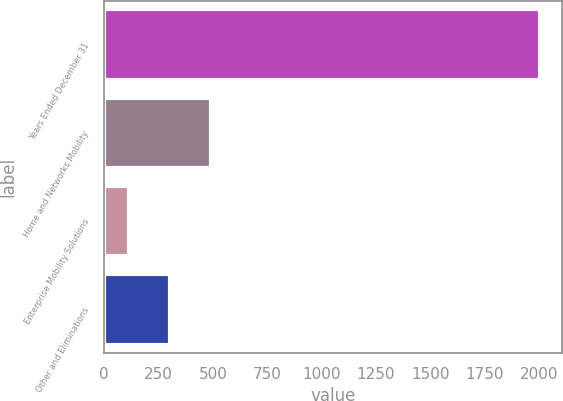Convert chart. <chart><loc_0><loc_0><loc_500><loc_500><bar_chart><fcel>Years Ended December 31<fcel>Home and Networks Mobility<fcel>Enterprise Mobility Solutions<fcel>Other and Eliminations<nl><fcel>2007<fcel>491.8<fcel>113<fcel>302.4<nl></chart> 